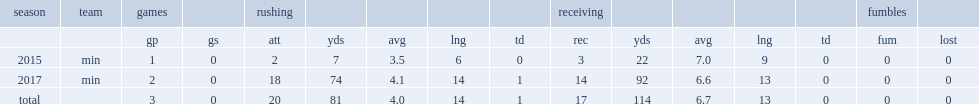How many yards did jerick mckinnon have in total? 114.0. 